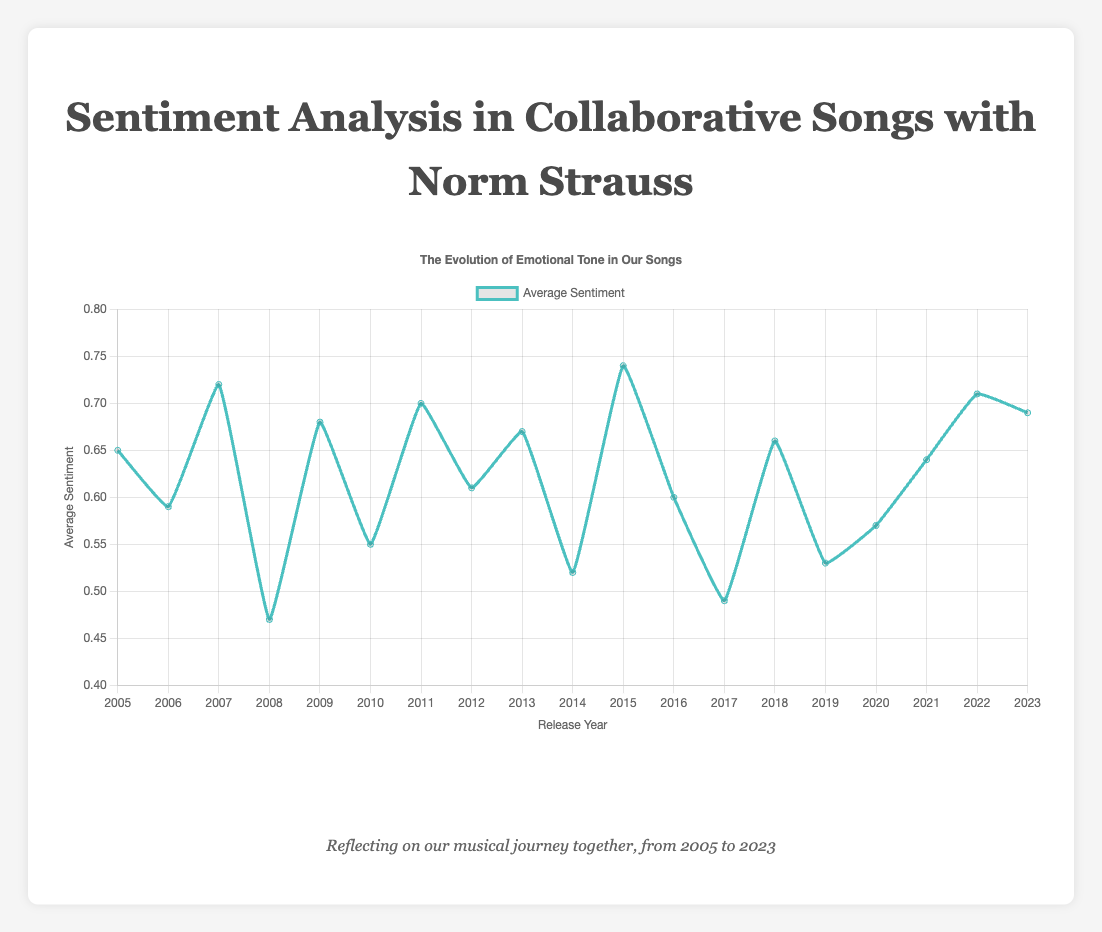Which song from 2012 has an average sentiment score of 0.61? The tooltip on the chart indicates that the song "Mountain Echo" was released in 2012 and has an average sentiment score of 0.61
Answer: "Mountain Echo" What is the overall trend in average sentiment from 2005 to 2023? Observing the line plot, there are fluctuations in sentiment scores, but there is no clear upward or downward trend over the entire period.
Answer: Fluctuating trend Which year had the highest average sentiment score and what was it? Looking at the highest point on the line plot, 2015 had the highest average sentiment score of 0.74.
Answer: 2015, 0.74 How many years had songs with an average sentiment greater than 0.65? By counting the points above the 0.65 sentiment line, the years are: 2007, 2009, 2011, 2013, 2015, 2018, 2022, and 2023, which totals to 8 years.
Answer: 8 years Which song had the lowest average sentiment and in which year was it released? The tooltip on the chart reveals that "Fading Memories" from 2008 had the lowest average sentiment score of 0.47.
Answer: "Fading Memories", 2008 How does the average sentiment score for "Whispers in the Wind" compare to "Silent Whispers"? The tooltip shows "Whispers in the Wind" (2021) has a score of 0.64, while "Silent Whispers" (2017) has a score of 0.49, meaning "Whispers in the Wind" has a higher sentiment score.
Answer: "Whispers in the Wind" is higher What is the average sentiment difference between "Golden Horizon" (2015) and "Winds of Change" (2014)? "Golden Horizon" has a score of 0.74, and "Winds of Change" has a score of 0.52. The difference is 0.74 - 0.52 = 0.22.
Answer: 0.22 Which consecutive years show a decline in sentiment score? Observing the line plot, the years showing consecutive declines are: 2007-2008, 2011-2012, 2015-2016, and 2016-2017.
Answer: 2007-2008, 2011-2012, 2015-2016, 2016-2017 What is the average sentiment score for all songs released between 2010 and 2015 inclusive? Songs and their scores are: 2010 (0.55), 2011 (0.70), 2012 (0.61), 2013 (0.67), 2014 (0.52), 2015 (0.74). Sum is 3.79. Average is 3.79/6 = 0.6317.
Answer: 0.63 